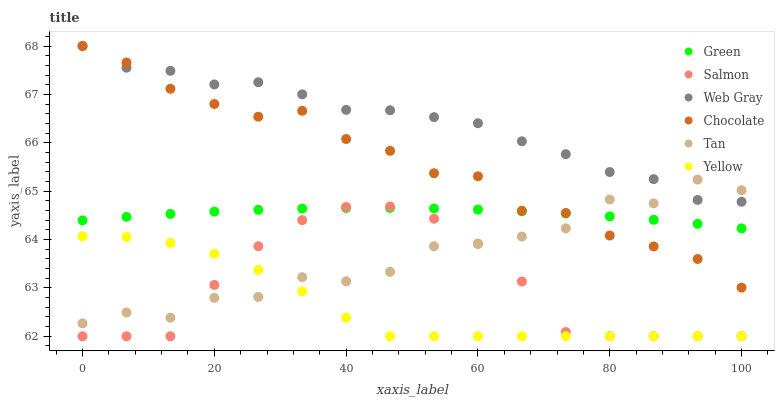Does Yellow have the minimum area under the curve?
Answer yes or no. Yes. Does Web Gray have the maximum area under the curve?
Answer yes or no. Yes. Does Salmon have the minimum area under the curve?
Answer yes or no. No. Does Salmon have the maximum area under the curve?
Answer yes or no. No. Is Green the smoothest?
Answer yes or no. Yes. Is Tan the roughest?
Answer yes or no. Yes. Is Salmon the smoothest?
Answer yes or no. No. Is Salmon the roughest?
Answer yes or no. No. Does Salmon have the lowest value?
Answer yes or no. Yes. Does Chocolate have the lowest value?
Answer yes or no. No. Does Chocolate have the highest value?
Answer yes or no. Yes. Does Salmon have the highest value?
Answer yes or no. No. Is Yellow less than Web Gray?
Answer yes or no. Yes. Is Green greater than Yellow?
Answer yes or no. Yes. Does Yellow intersect Tan?
Answer yes or no. Yes. Is Yellow less than Tan?
Answer yes or no. No. Is Yellow greater than Tan?
Answer yes or no. No. Does Yellow intersect Web Gray?
Answer yes or no. No. 